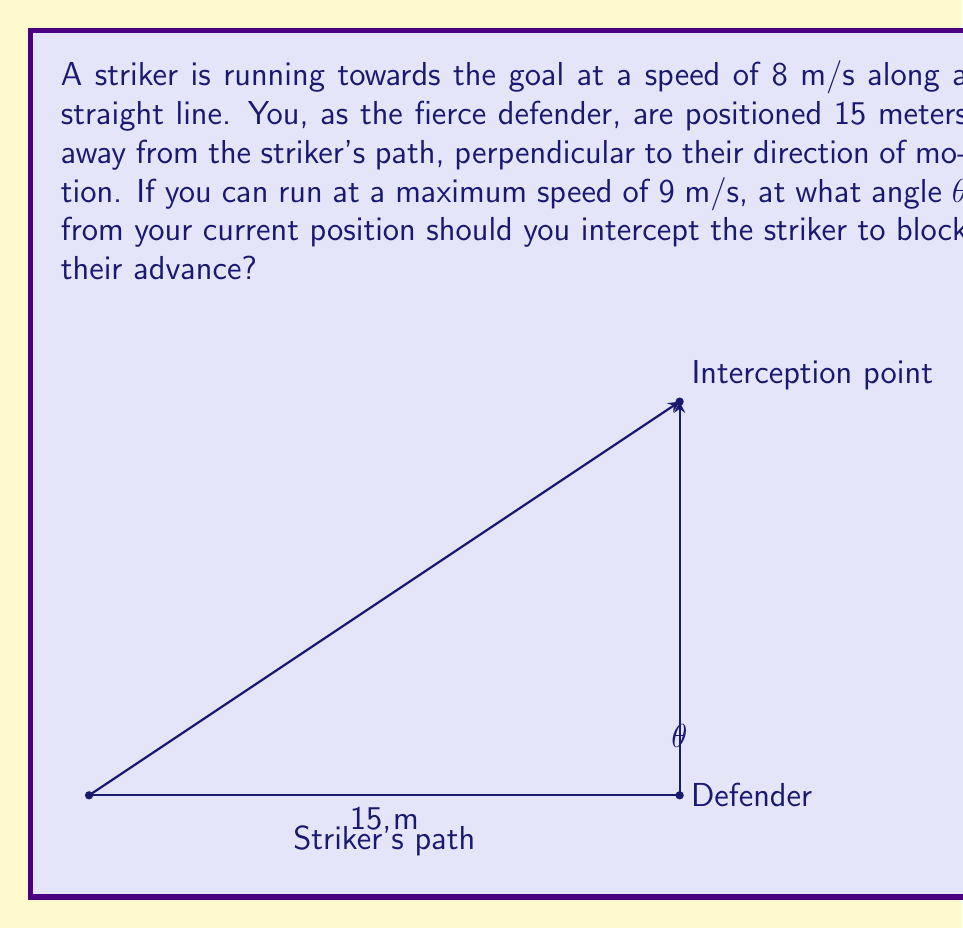Can you solve this math problem? Let's approach this step-by-step:

1) First, we need to understand that the optimal interception path forms a right triangle with the striker's path and the defender's initial position.

2) Let's denote the time to interception as $t$. During this time:
   - The striker covers a distance of $8t$ meters
   - The defender covers a distance of $9t$ meters (hypotenuse of the triangle)

3) Using the Pythagorean theorem:
   $$(8t)^2 + 15^2 = (9t)^2$$

4) Simplifying:
   $$64t^2 + 225 = 81t^2$$

5) Rearranging:
   $$17t^2 = 225$$
   $$t^2 = \frac{225}{17}$$
   $$t = \sqrt{\frac{225}{17}} \approx 3.64 \text{ seconds}$$

6) Now, we can find the distance the striker travels:
   $$8t = 8 \cdot \sqrt{\frac{225}{17}} \approx 29.12 \text{ meters}$$

7) We now have a right triangle with sides 15 and 29.12 meters. We can find the angle using trigonometry:

   $$\tan \theta = \frac{29.12}{15}$$
   $$\theta = \arctan(\frac{29.12}{15})$$

8) Calculating this:
   $$\theta \approx 62.73°$$
Answer: $62.73°$ 